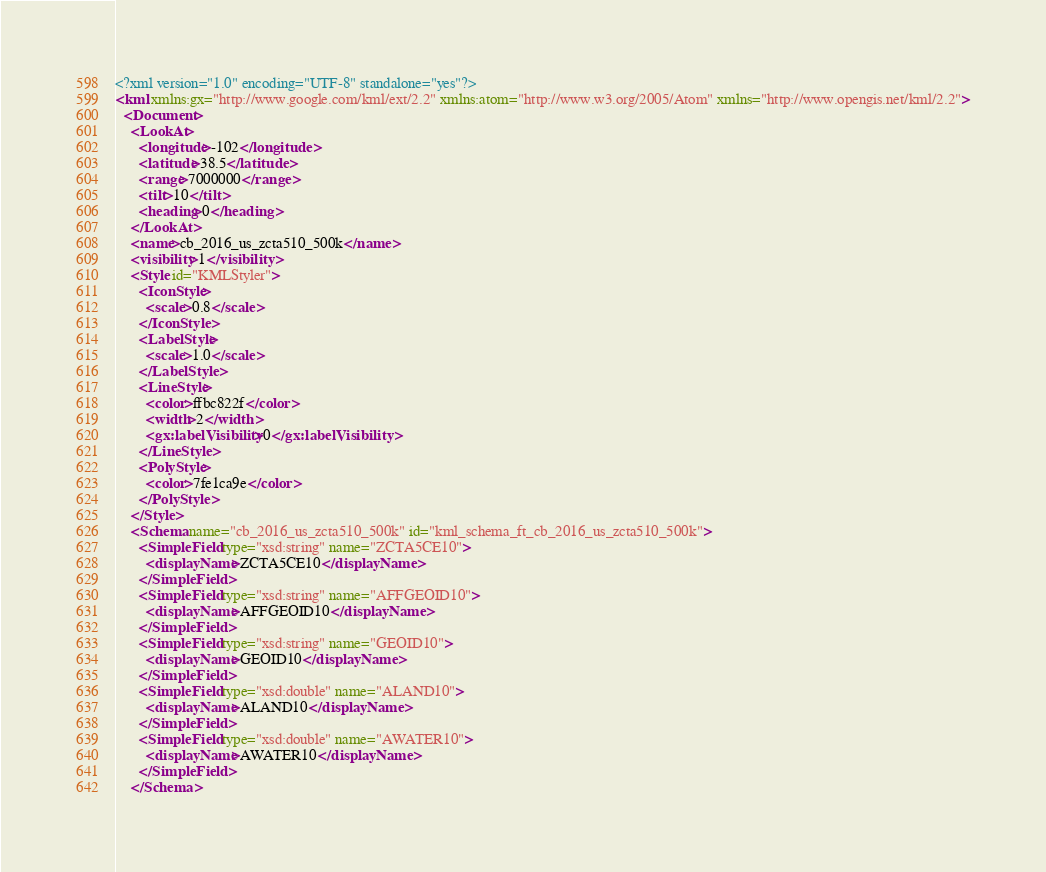Convert code to text. <code><loc_0><loc_0><loc_500><loc_500><_XML_><?xml version="1.0" encoding="UTF-8" standalone="yes"?>
<kml xmlns:gx="http://www.google.com/kml/ext/2.2" xmlns:atom="http://www.w3.org/2005/Atom" xmlns="http://www.opengis.net/kml/2.2">
  <Document>
    <LookAt>
      <longitude>-102</longitude>
      <latitude>38.5</latitude>
      <range>7000000</range>
      <tilt>10</tilt>
      <heading>0</heading>
    </LookAt>
    <name>cb_2016_us_zcta510_500k</name>
    <visibility>1</visibility>
    <Style id="KMLStyler">
      <IconStyle>
        <scale>0.8</scale>
      </IconStyle>
      <LabelStyle>
        <scale>1.0</scale>
      </LabelStyle>
      <LineStyle>
        <color>ffbc822f</color>
        <width>2</width>
        <gx:labelVisibility>0</gx:labelVisibility>
      </LineStyle>
      <PolyStyle>
        <color>7fe1ca9e</color>
      </PolyStyle>
    </Style>
    <Schema name="cb_2016_us_zcta510_500k" id="kml_schema_ft_cb_2016_us_zcta510_500k">
      <SimpleField type="xsd:string" name="ZCTA5CE10">
        <displayName>ZCTA5CE10</displayName>
      </SimpleField>
      <SimpleField type="xsd:string" name="AFFGEOID10">
        <displayName>AFFGEOID10</displayName>
      </SimpleField>
      <SimpleField type="xsd:string" name="GEOID10">
        <displayName>GEOID10</displayName>
      </SimpleField>
      <SimpleField type="xsd:double" name="ALAND10">
        <displayName>ALAND10</displayName>
      </SimpleField>
      <SimpleField type="xsd:double" name="AWATER10">
        <displayName>AWATER10</displayName>
      </SimpleField>
    </Schema></code> 